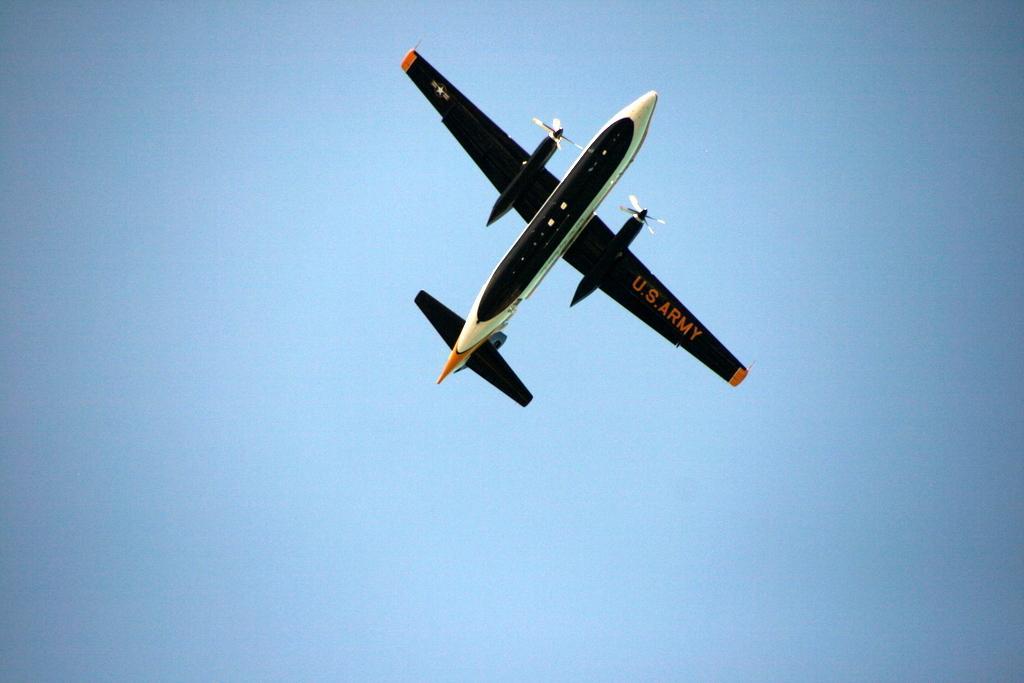Please provide a concise description of this image. In this image we can see an airplane in the sky. 